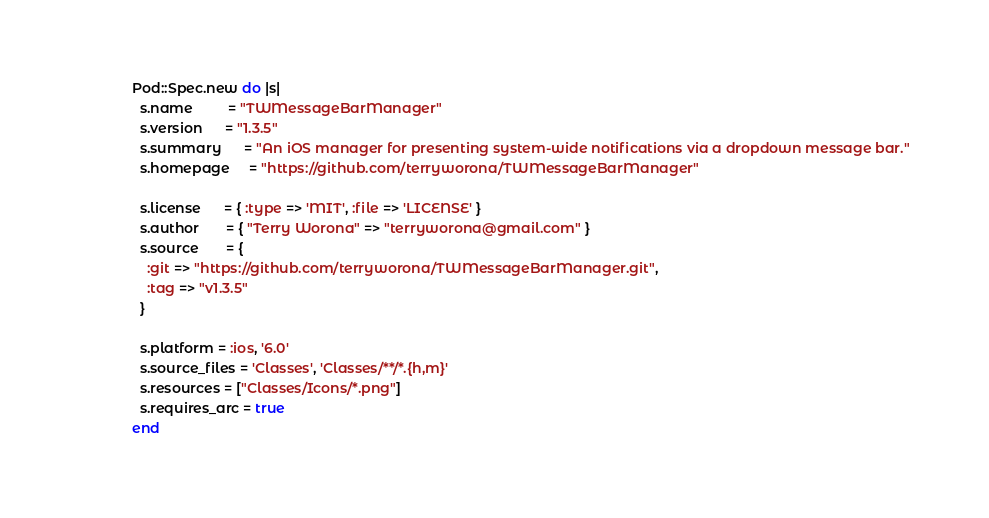Convert code to text. <code><loc_0><loc_0><loc_500><loc_500><_Ruby_>Pod::Spec.new do |s|
  s.name         = "TWMessageBarManager"
  s.version      = "1.3.5"
  s.summary      = "An iOS manager for presenting system-wide notifications via a dropdown message bar."
  s.homepage     = "https://github.com/terryworona/TWMessageBarManager"

  s.license      = { :type => 'MIT', :file => 'LICENSE' }
  s.author       = { "Terry Worona" => "terryworona@gmail.com" }
  s.source       = { 
	:git => "https://github.com/terryworona/TWMessageBarManager.git",
	:tag => "v1.3.5"
  }

  s.platform = :ios, '6.0'
  s.source_files = 'Classes', 'Classes/**/*.{h,m}'
  s.resources = ["Classes/Icons/*.png"]
  s.requires_arc = true
end
</code> 